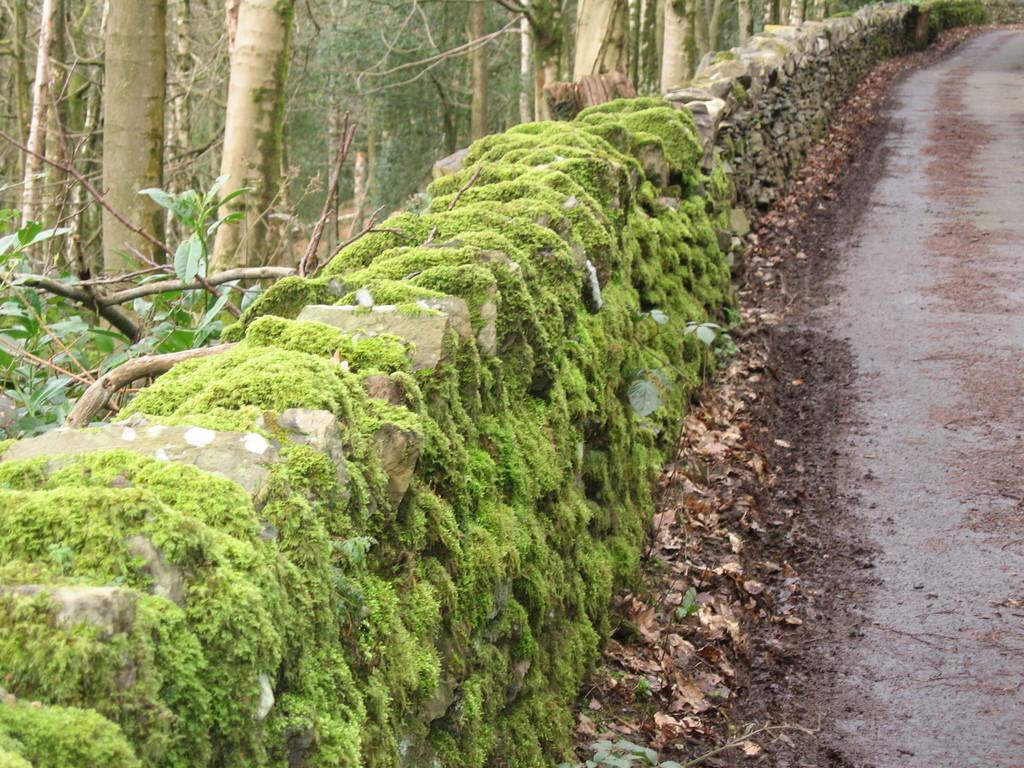What is covering the wall in the image? There is a wall covered with moss in the image. What type of surface is on the right side of the image? There is pavement on the right side of the image. What type of vegetation can be seen on the ground in the image? Dry leaves are visible in the image. Where are the trees located in the image? There are trees in the left top of the image. What type of butter is being used to grease the trees in the image? There is no butter present in the image, and the trees are not being greased. How many family members are visible in the image? There are no family members present in the image. 